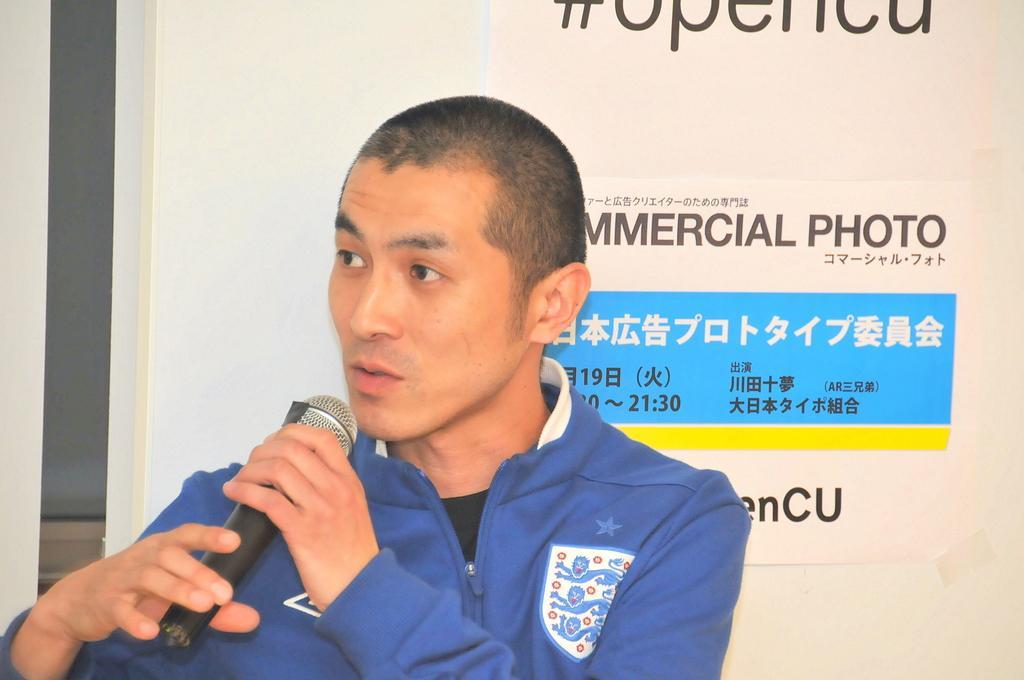Describe this image in one or two sentences. In this image we can see a man is holding a microphone in the hands, he is wearing the blue jacket, at back here is the matter something written on it. 